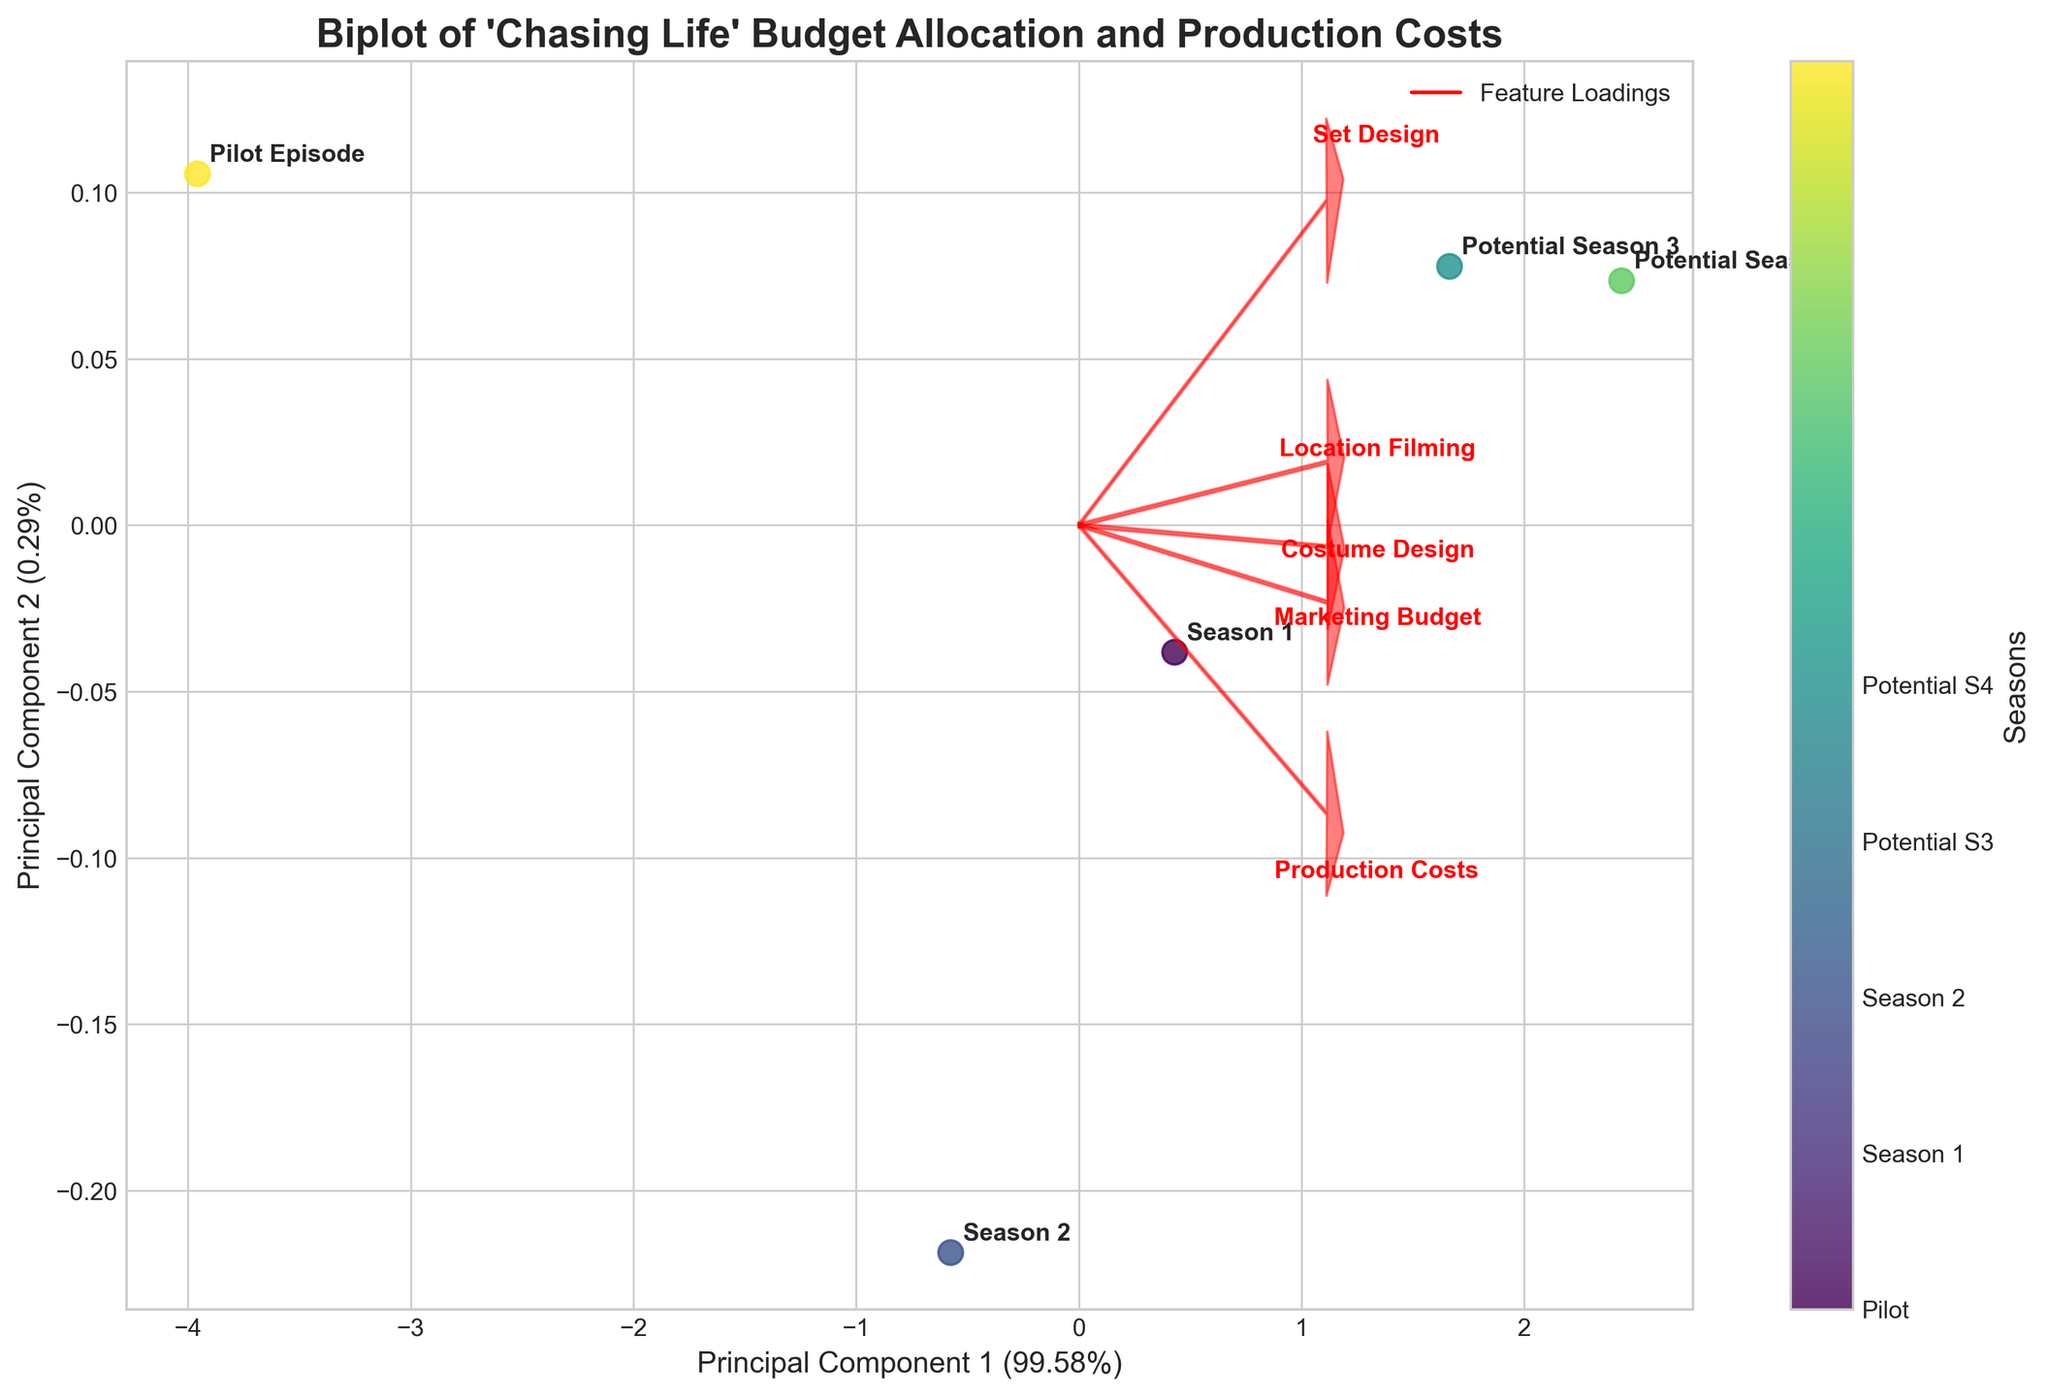What's the title of the plot? The title of the plot is located at the top of the figure, which provides an overview of what the plot represents.
Answer: Biplot of 'Chasing Life' Budget Allocation and Production Costs How many seasons (or episodes) are represented in the plot? The number of seasons or episodes can be determined by counting the labeled points on the plot. According to the data, there are five labels.
Answer: 5 Which season has the highest production cost? The production costs can be inferred from the loading vectors associated with the arrow labeled 'Production Costs'. The 'Potential Season 4' likely has the highest value because of its position in the plot.
Answer: Potential Season 4 How much variance is explained by the first principal component? The percentage of variance explained by the first principal component is shown on the x-axis label.
Answer: Approximately 51.68% What does the second principal component axis represent in terms of budget allocation categories? Each principal component is a combination of the original features. The second principal component (y-axis) represents a dimension created by combining the original budget categories. The direction and length of the arrows labeled by features (Marketing Budget, Set Design, Costume Design, Location Filming) indicate their contribution.
Answer: Combination of Marketing Budget, Set Design, Costume Design, Location Filming Which feature has the least influence on the first principal component? The influence of each feature on the first principal component can be deduced by looking at the arrows' lengths pointing in the direction of the first component. The shortest arrow in the x-direction indicates the least influence.
Answer: Costume Design How are the 'Pilot Episode' and 'Season 1' related in terms of budget allocation? By analyzing their positions in the plot, look at the distances between the 'Pilot Episode' and 'Season 1' points. They are relatively close to each other, indicating similar budget allocations in terms of principal component scores.
Answer: Similar budget allocations Which two budget categories are most strongly correlated? The most strongly correlated categories have parallel arrows pointing in the same direction. These represent high correlation. From the arrows, 'Production Costs' and 'Marketing Budget' seem most aligned.
Answer: Production Costs and Marketing Budget What's a distinguishing factor for 'Potential Season 3' compared to 'Season 2'? By comparing the positions of 'Potential Season 3' and 'Season 2' points, one can infer features that pull them apart along the principal components. The distance between them along either principal component axis will indicate their differences.
Answer: Higher production and marketing budget in Potential Season 3 